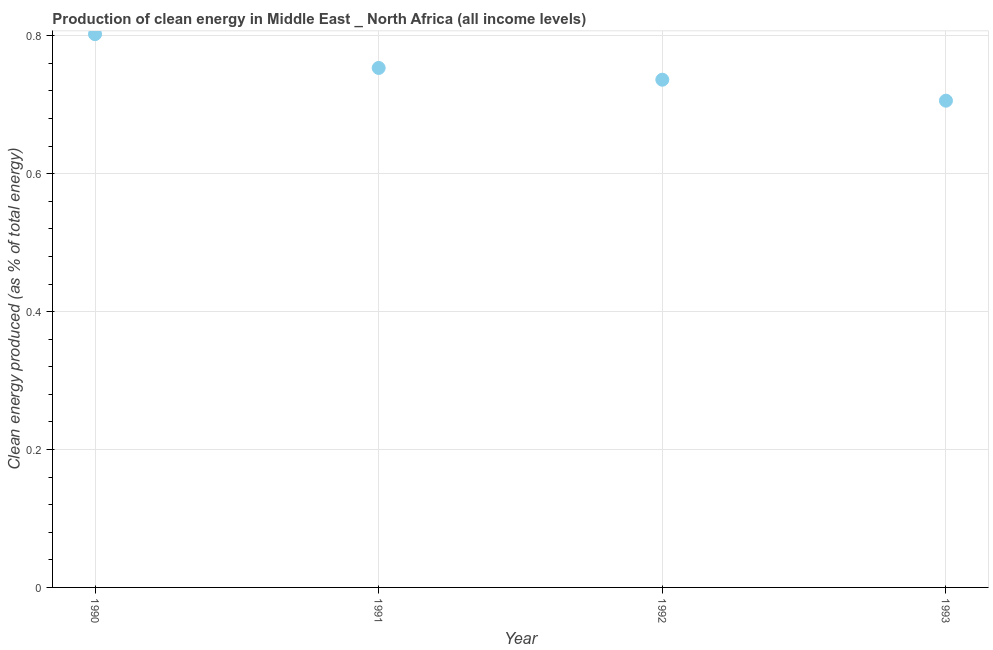What is the production of clean energy in 1990?
Your answer should be very brief. 0.8. Across all years, what is the maximum production of clean energy?
Make the answer very short. 0.8. Across all years, what is the minimum production of clean energy?
Offer a very short reply. 0.71. In which year was the production of clean energy maximum?
Offer a terse response. 1990. What is the sum of the production of clean energy?
Your answer should be very brief. 3. What is the difference between the production of clean energy in 1992 and 1993?
Make the answer very short. 0.03. What is the average production of clean energy per year?
Ensure brevity in your answer.  0.75. What is the median production of clean energy?
Keep it short and to the point. 0.74. What is the ratio of the production of clean energy in 1990 to that in 1992?
Make the answer very short. 1.09. Is the production of clean energy in 1990 less than that in 1991?
Make the answer very short. No. Is the difference between the production of clean energy in 1990 and 1993 greater than the difference between any two years?
Offer a very short reply. Yes. What is the difference between the highest and the second highest production of clean energy?
Provide a short and direct response. 0.05. What is the difference between the highest and the lowest production of clean energy?
Keep it short and to the point. 0.1. How many dotlines are there?
Your response must be concise. 1. How many years are there in the graph?
Make the answer very short. 4. What is the difference between two consecutive major ticks on the Y-axis?
Make the answer very short. 0.2. Are the values on the major ticks of Y-axis written in scientific E-notation?
Your response must be concise. No. Does the graph contain any zero values?
Give a very brief answer. No. What is the title of the graph?
Your answer should be compact. Production of clean energy in Middle East _ North Africa (all income levels). What is the label or title of the Y-axis?
Provide a succinct answer. Clean energy produced (as % of total energy). What is the Clean energy produced (as % of total energy) in 1990?
Offer a terse response. 0.8. What is the Clean energy produced (as % of total energy) in 1991?
Your answer should be compact. 0.75. What is the Clean energy produced (as % of total energy) in 1992?
Give a very brief answer. 0.74. What is the Clean energy produced (as % of total energy) in 1993?
Ensure brevity in your answer.  0.71. What is the difference between the Clean energy produced (as % of total energy) in 1990 and 1991?
Keep it short and to the point. 0.05. What is the difference between the Clean energy produced (as % of total energy) in 1990 and 1992?
Your answer should be compact. 0.07. What is the difference between the Clean energy produced (as % of total energy) in 1990 and 1993?
Give a very brief answer. 0.1. What is the difference between the Clean energy produced (as % of total energy) in 1991 and 1992?
Your answer should be very brief. 0.02. What is the difference between the Clean energy produced (as % of total energy) in 1991 and 1993?
Offer a very short reply. 0.05. What is the difference between the Clean energy produced (as % of total energy) in 1992 and 1993?
Keep it short and to the point. 0.03. What is the ratio of the Clean energy produced (as % of total energy) in 1990 to that in 1991?
Your answer should be compact. 1.06. What is the ratio of the Clean energy produced (as % of total energy) in 1990 to that in 1992?
Give a very brief answer. 1.09. What is the ratio of the Clean energy produced (as % of total energy) in 1990 to that in 1993?
Ensure brevity in your answer.  1.14. What is the ratio of the Clean energy produced (as % of total energy) in 1991 to that in 1992?
Provide a short and direct response. 1.02. What is the ratio of the Clean energy produced (as % of total energy) in 1991 to that in 1993?
Your answer should be compact. 1.07. What is the ratio of the Clean energy produced (as % of total energy) in 1992 to that in 1993?
Your response must be concise. 1.04. 